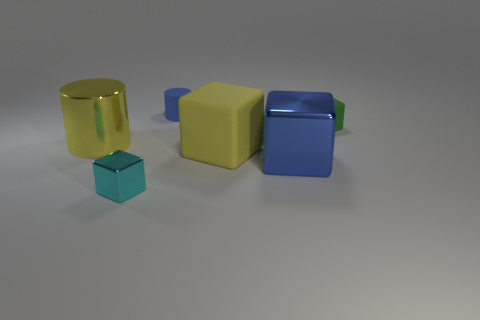Subtract all big blue shiny cubes. How many cubes are left? 3 Add 3 big blue shiny cubes. How many objects exist? 9 Subtract all green cubes. How many cubes are left? 3 Subtract all cylinders. How many objects are left? 4 Subtract 1 cubes. How many cubes are left? 3 Add 2 large blue shiny things. How many large blue shiny things are left? 3 Add 3 tiny cyan objects. How many tiny cyan objects exist? 4 Subtract 1 blue cylinders. How many objects are left? 5 Subtract all yellow cubes. Subtract all cyan cylinders. How many cubes are left? 3 Subtract all large yellow metallic things. Subtract all blue metallic things. How many objects are left? 4 